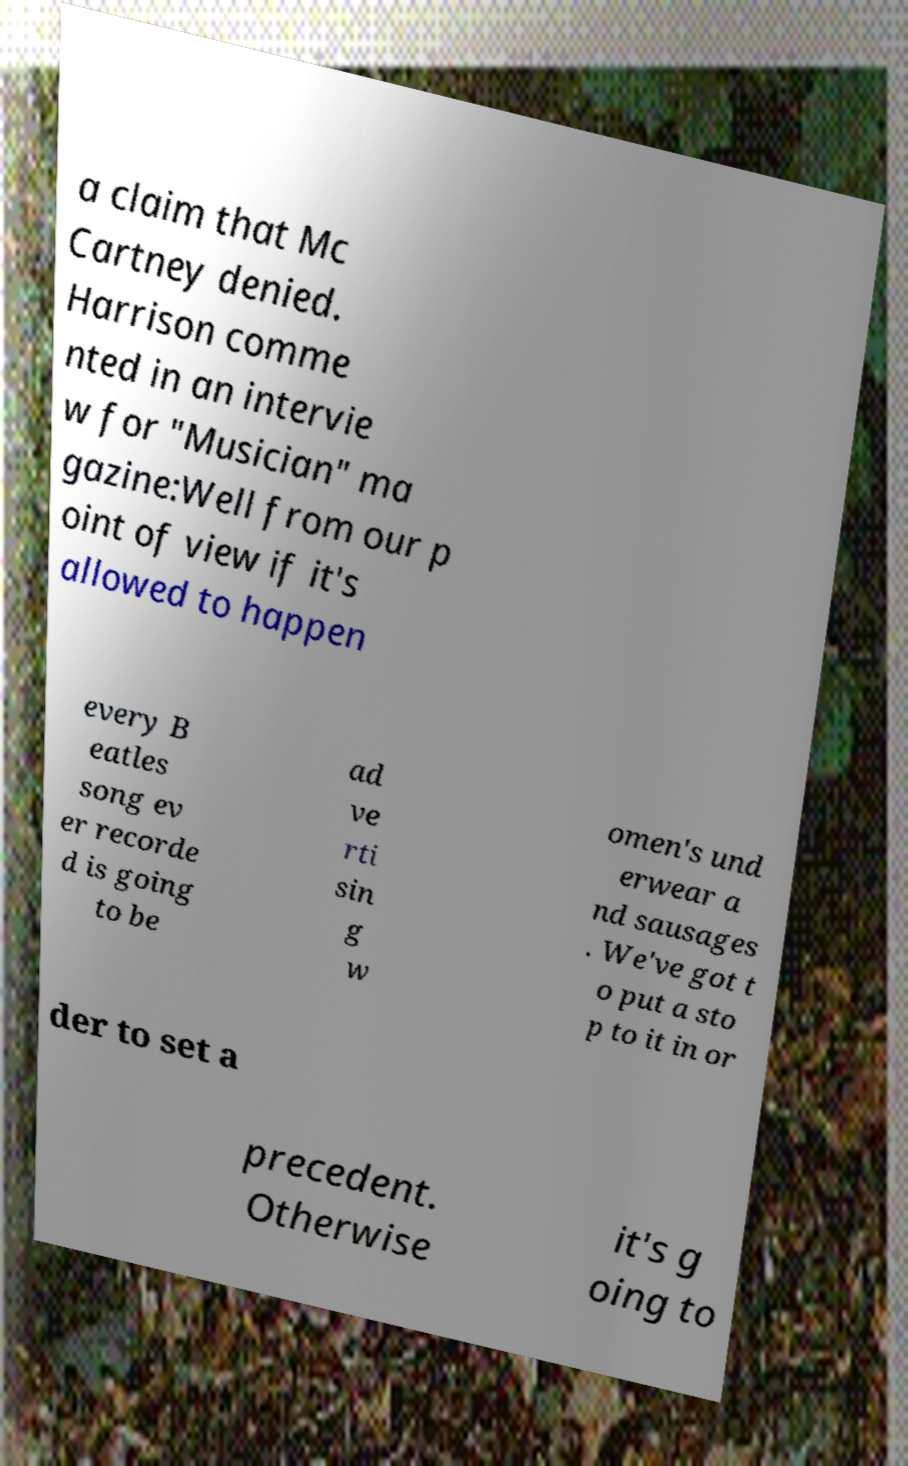What messages or text are displayed in this image? I need them in a readable, typed format. a claim that Mc Cartney denied. Harrison comme nted in an intervie w for "Musician" ma gazine:Well from our p oint of view if it's allowed to happen every B eatles song ev er recorde d is going to be ad ve rti sin g w omen's und erwear a nd sausages . We've got t o put a sto p to it in or der to set a precedent. Otherwise it's g oing to 